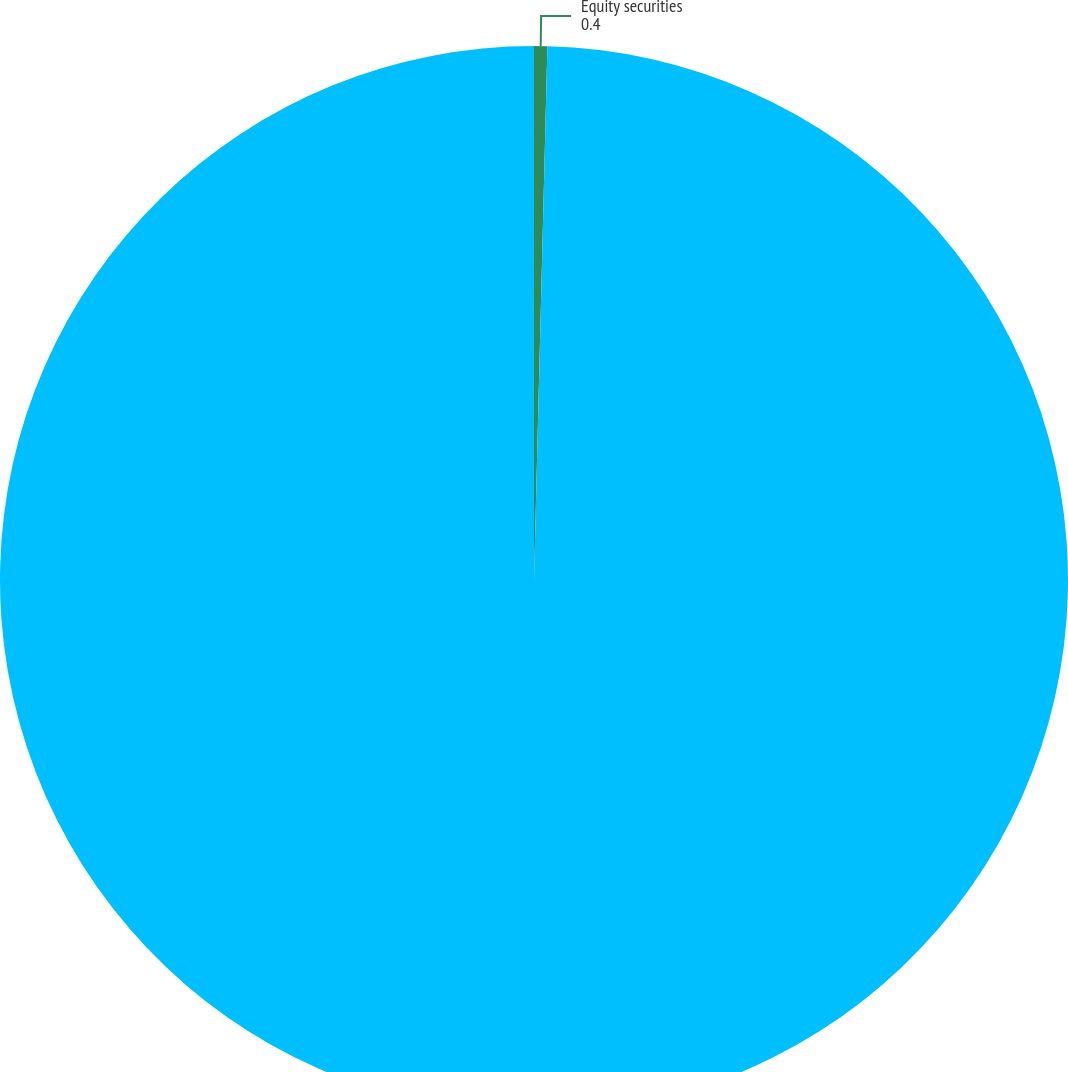Convert chart. <chart><loc_0><loc_0><loc_500><loc_500><pie_chart><fcel>Equity securities<fcel>Investments of insurance<nl><fcel>0.4%<fcel>99.6%<nl></chart> 